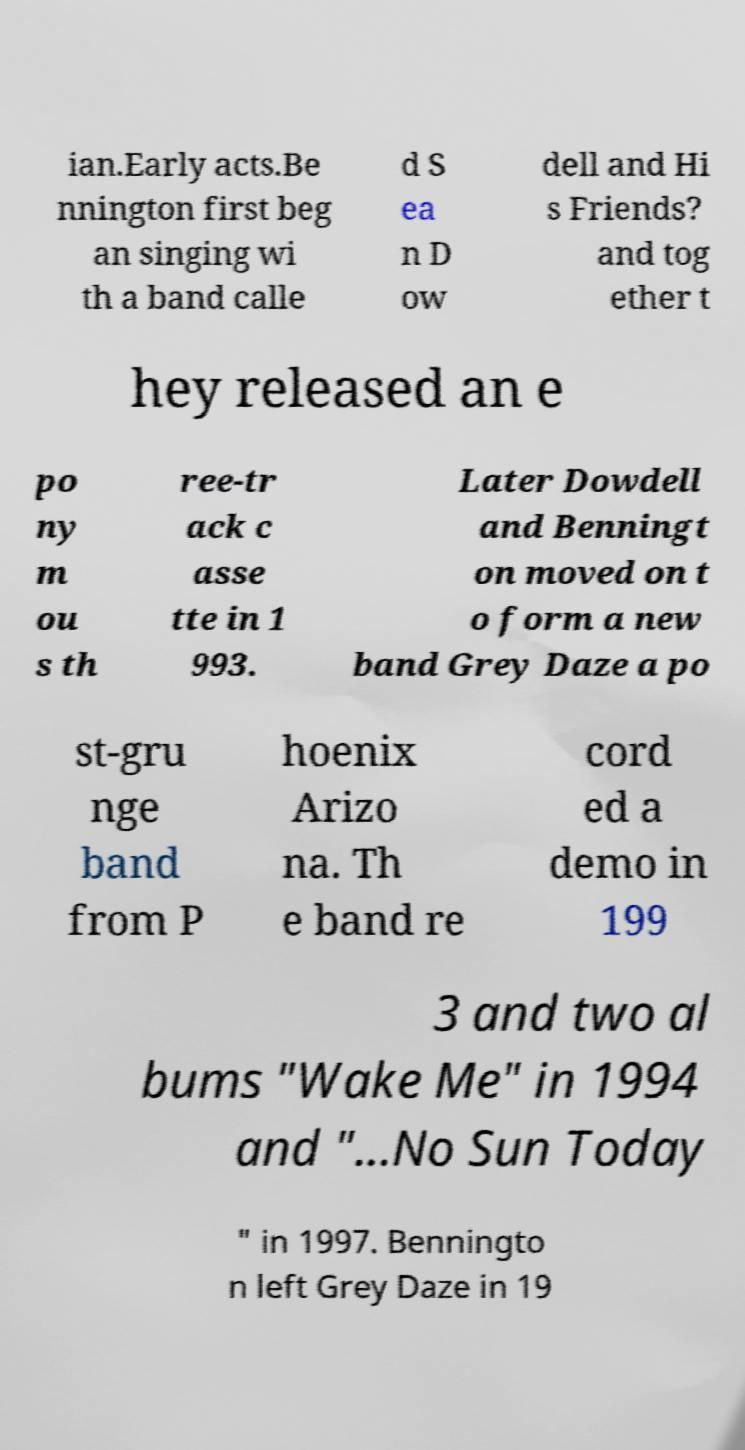Please read and relay the text visible in this image. What does it say? ian.Early acts.Be nnington first beg an singing wi th a band calle d S ea n D ow dell and Hi s Friends? and tog ether t hey released an e po ny m ou s th ree-tr ack c asse tte in 1 993. Later Dowdell and Benningt on moved on t o form a new band Grey Daze a po st-gru nge band from P hoenix Arizo na. Th e band re cord ed a demo in 199 3 and two al bums "Wake Me" in 1994 and "...No Sun Today " in 1997. Benningto n left Grey Daze in 19 